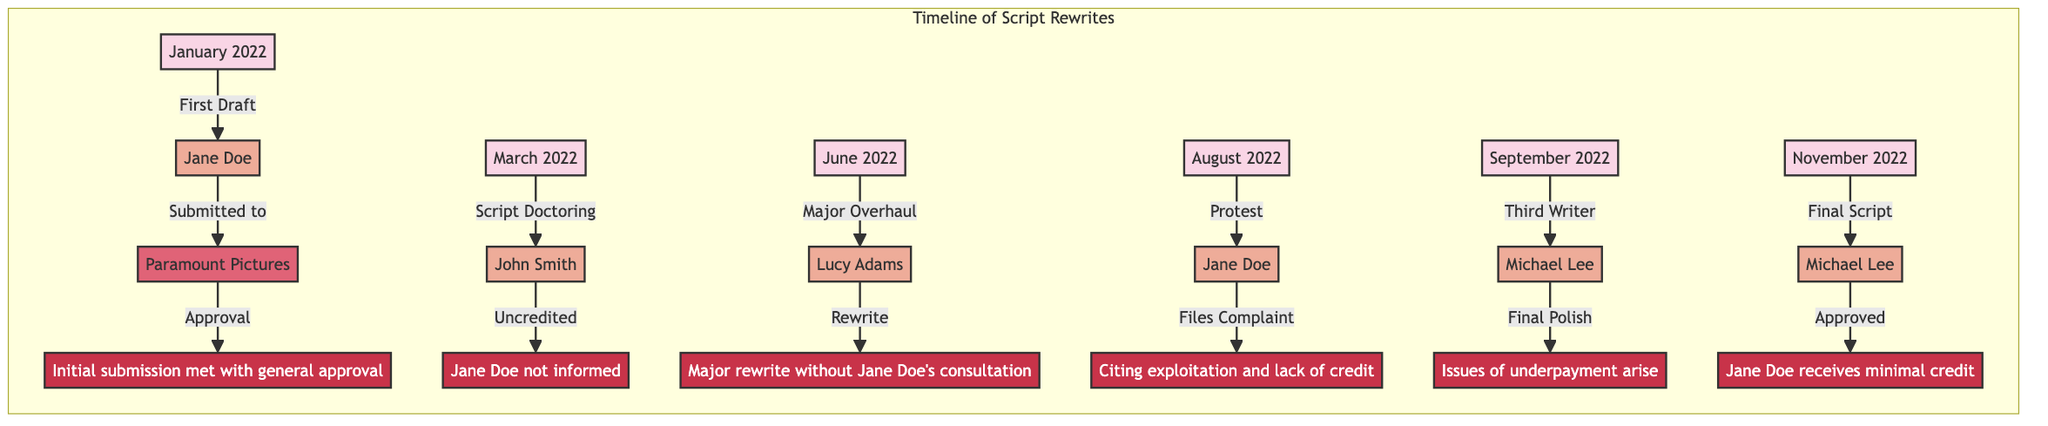What date was the first draft submitted? The first draft was submitted on January 2022, as indicated by the first event in the timeline.
Answer: January 2022 Who was the original writer of the script? The original writer is Jane Doe, who is noted in the first event for submitting the initial draft.
Answer: Jane Doe What major event happened in June 2022? In June 2022, a major overhaul occurred, which is the event noted in that month, indicating significant changes took place.
Answer: Major Overhaul How many writers were involved in the script rewrites? Five writers were involved as noted in the events: Jane Doe, John Smith, Lucy Adams, Michael Lee (twice), totaling five mentions of unique writers.
Answer: Five What was the outcome of the protest filed by Jane Doe? The outcome of the protest cited exploitation and lack of credit, as referenced in the notes for August 2022.
Answer: Exploitation and lack of credit What issue arose when Michael Lee was introduced for final polish? The issue that arose was underpayment, which is stated in the note for September 2022, highlighting financial concerns during the final touches.
Answer: Underpayment What studio was involved in all the script rewrites? The studio involved is Paramount Pictures, as it is mentioned alongside each of the events in the timeline.
Answer: Paramount Pictures Who received minimal credit in November 2022? In November 2022, Jane Doe received minimal credit as noted in the final script locked event.
Answer: Jane Doe Why was the first draft of the script submitted? The first draft was submitted for general approval, as noted in the details of the first event in January 2022.
Answer: General approval 